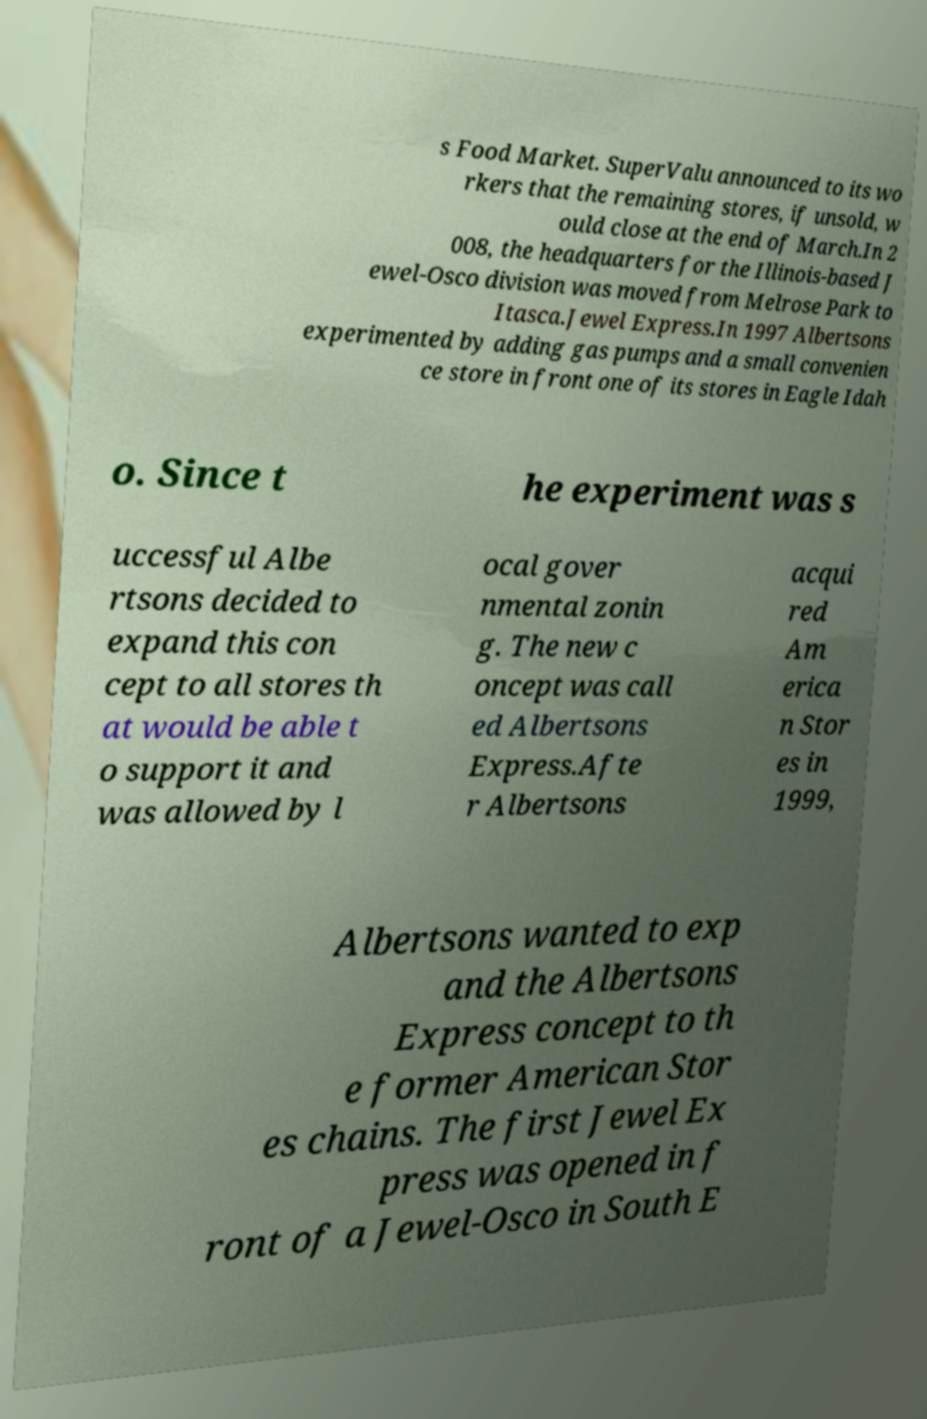Can you accurately transcribe the text from the provided image for me? s Food Market. SuperValu announced to its wo rkers that the remaining stores, if unsold, w ould close at the end of March.In 2 008, the headquarters for the Illinois-based J ewel-Osco division was moved from Melrose Park to Itasca.Jewel Express.In 1997 Albertsons experimented by adding gas pumps and a small convenien ce store in front one of its stores in Eagle Idah o. Since t he experiment was s uccessful Albe rtsons decided to expand this con cept to all stores th at would be able t o support it and was allowed by l ocal gover nmental zonin g. The new c oncept was call ed Albertsons Express.Afte r Albertsons acqui red Am erica n Stor es in 1999, Albertsons wanted to exp and the Albertsons Express concept to th e former American Stor es chains. The first Jewel Ex press was opened in f ront of a Jewel-Osco in South E 